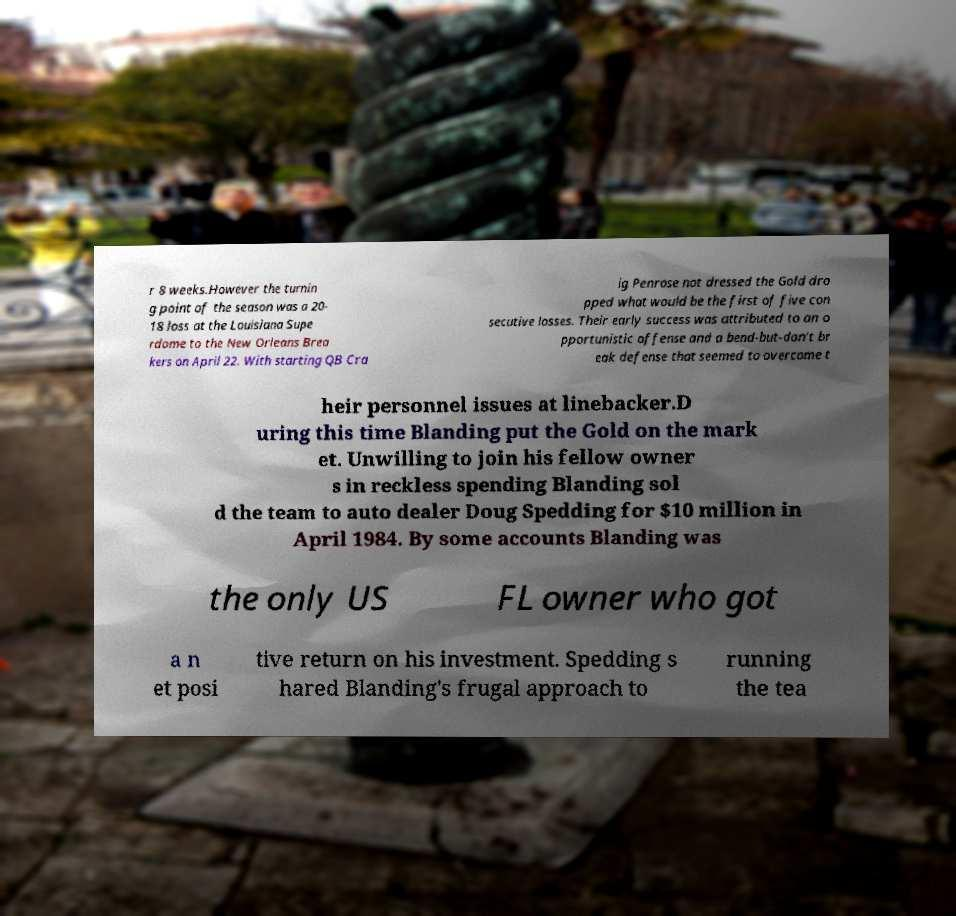Could you extract and type out the text from this image? r 8 weeks.However the turnin g point of the season was a 20- 18 loss at the Louisiana Supe rdome to the New Orleans Brea kers on April 22. With starting QB Cra ig Penrose not dressed the Gold dro pped what would be the first of five con secutive losses. Their early success was attributed to an o pportunistic offense and a bend-but-don't br eak defense that seemed to overcome t heir personnel issues at linebacker.D uring this time Blanding put the Gold on the mark et. Unwilling to join his fellow owner s in reckless spending Blanding sol d the team to auto dealer Doug Spedding for $10 million in April 1984. By some accounts Blanding was the only US FL owner who got a n et posi tive return on his investment. Spedding s hared Blanding's frugal approach to running the tea 